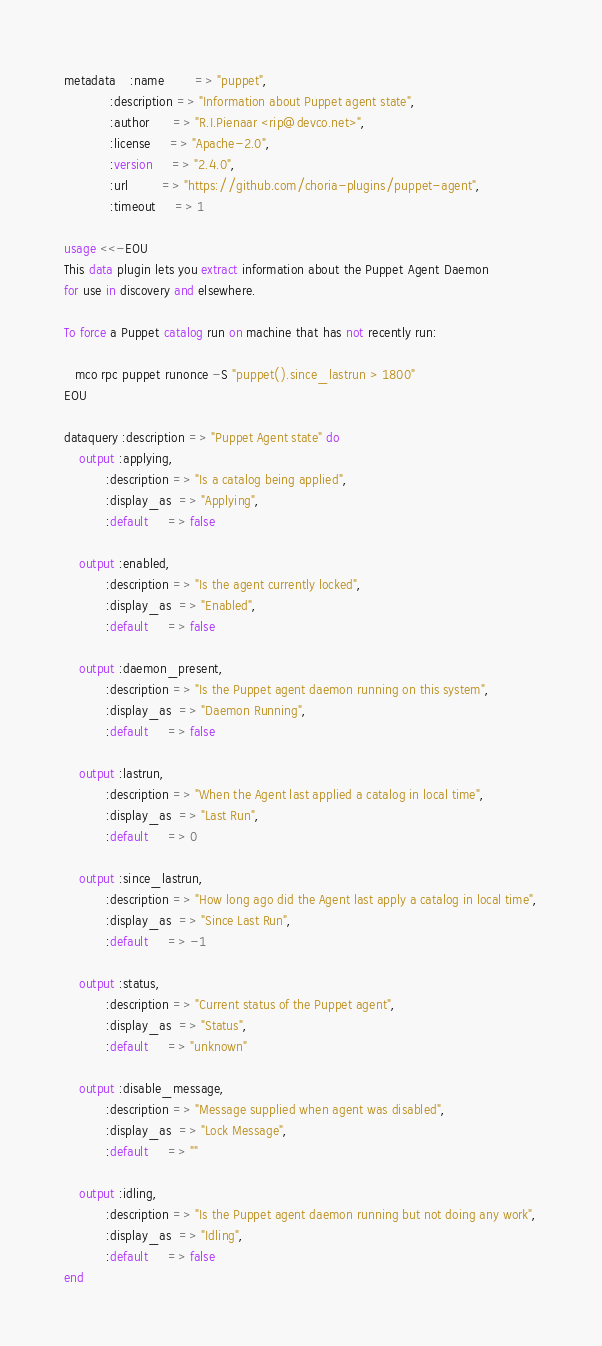Convert code to text. <code><loc_0><loc_0><loc_500><loc_500><_SQL_>metadata    :name        => "puppet",
            :description => "Information about Puppet agent state",
            :author      => "R.I.Pienaar <rip@devco.net>",
            :license     => "Apache-2.0",
            :version     => "2.4.0",
            :url         => "https://github.com/choria-plugins/puppet-agent",
            :timeout     => 1

usage <<-EOU
This data plugin lets you extract information about the Puppet Agent Daemon
for use in discovery and elsewhere.

To force a Puppet catalog run on machine that has not recently run:

   mco rpc puppet runonce -S "puppet().since_lastrun > 1800"
EOU

dataquery :description => "Puppet Agent state" do
    output :applying,
           :description => "Is a catalog being applied",
           :display_as  => "Applying",
           :default     => false

    output :enabled,
           :description => "Is the agent currently locked",
           :display_as  => "Enabled",
           :default     => false

    output :daemon_present,
           :description => "Is the Puppet agent daemon running on this system",
           :display_as  => "Daemon Running",
           :default     => false

    output :lastrun,
           :description => "When the Agent last applied a catalog in local time",
           :display_as  => "Last Run",
           :default     => 0

    output :since_lastrun,
           :description => "How long ago did the Agent last apply a catalog in local time",
           :display_as  => "Since Last Run",
           :default     => -1

    output :status,
           :description => "Current status of the Puppet agent",
           :display_as  => "Status",
           :default     => "unknown"

    output :disable_message,
           :description => "Message supplied when agent was disabled",
           :display_as  => "Lock Message",
           :default     => ""

    output :idling,
           :description => "Is the Puppet agent daemon running but not doing any work",
           :display_as  => "Idling",
           :default     => false
end
</code> 